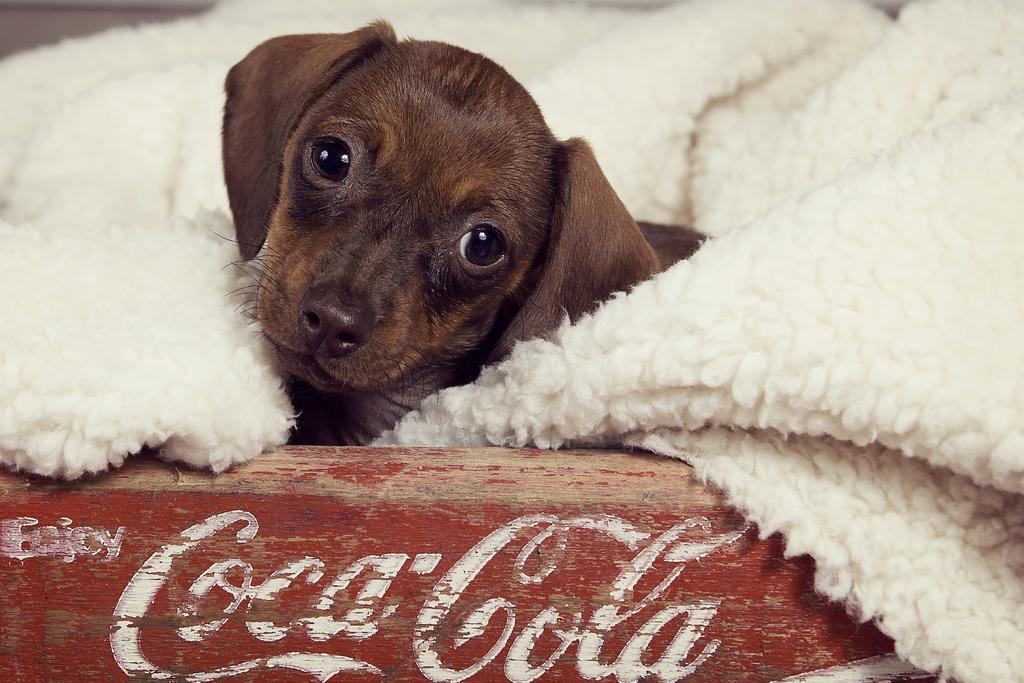Please provide a concise description of this image. There is a brown puppy. Surrounded by it there is a white blanket. 